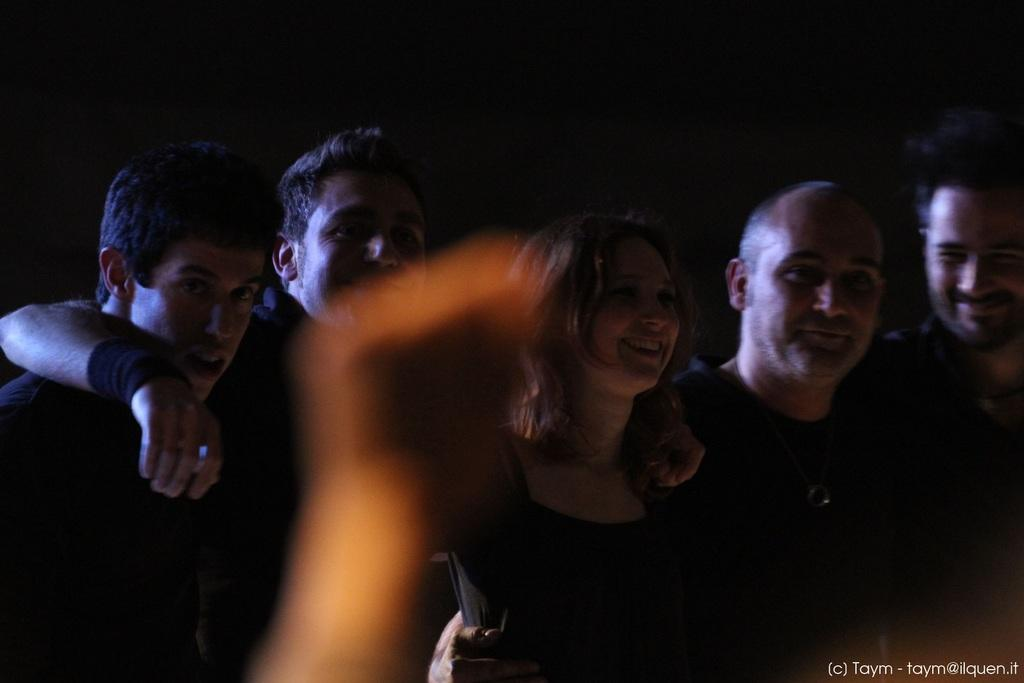How many people are in the image? There is a group of people in the image. What are the people in the image doing? The people are standing. Can you describe any specific body part that is visible in the image? The hand of a person is visible in the foreground of the image. What type of space is visible in the image? There is no space visible in the image; it features a group of people standing. Can you describe the waves in the image? There are no waves present in the image. 